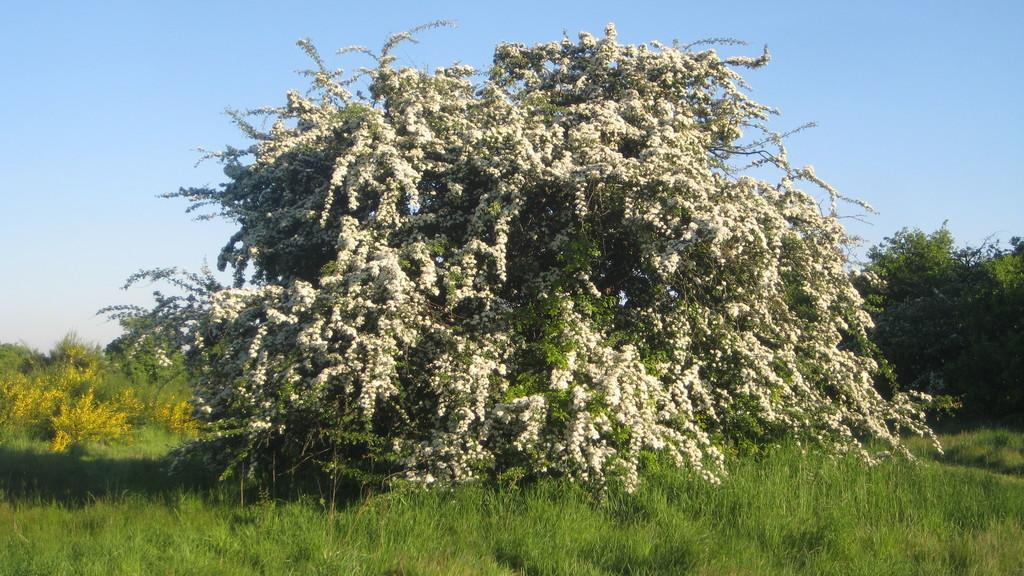What type of living organisms can be seen in the image? Plants can be seen in the image. Where are the plants located in relation to the ground? The plants are on the ground. What type of vegetation covers the ground in the image? The ground is covered with grass. What advice is the sister giving to the committee at the camp in the image? There is no sister, committee, or camp present in the image; it only features plants on the ground covered with grass. 